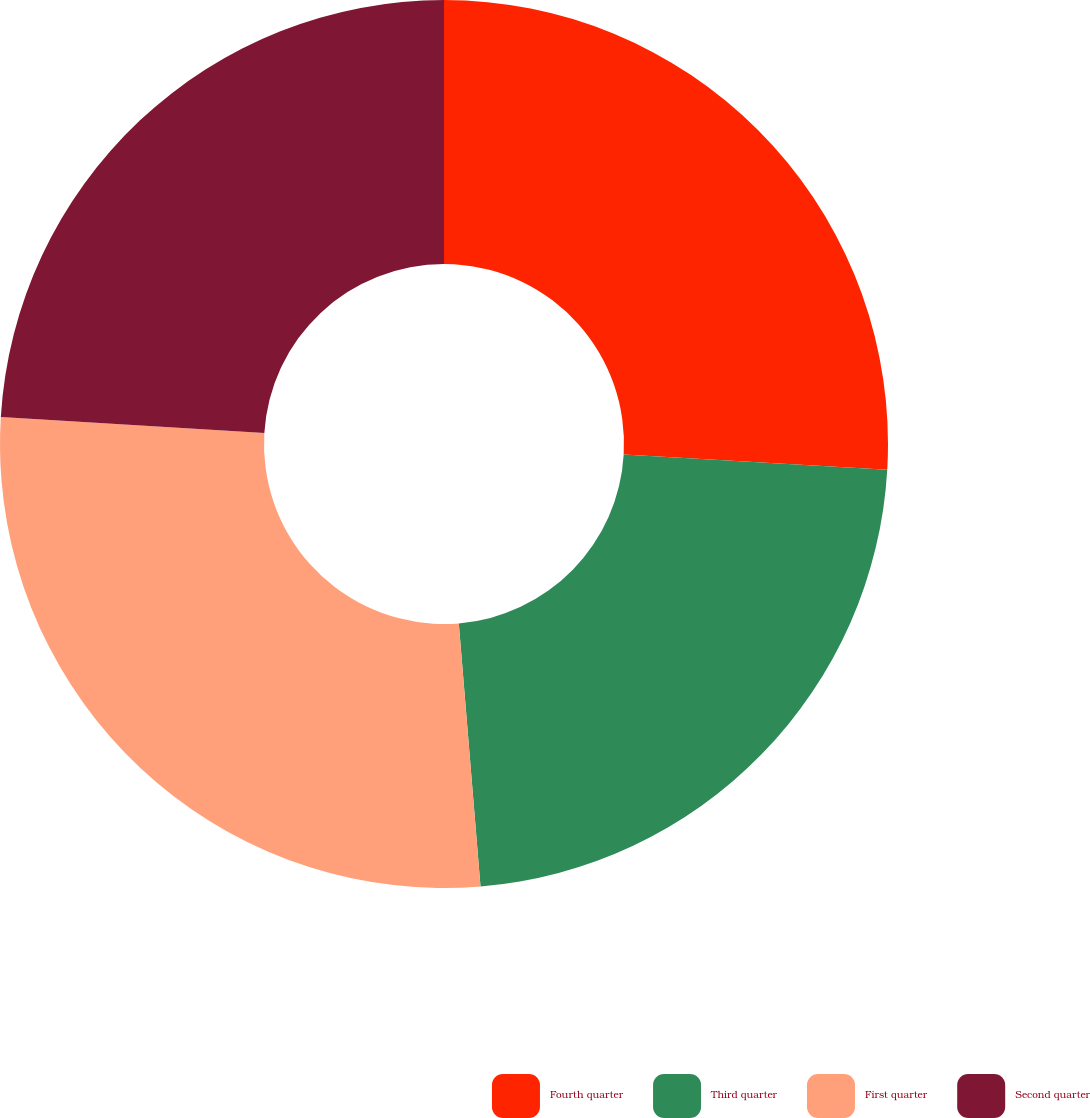Convert chart to OTSL. <chart><loc_0><loc_0><loc_500><loc_500><pie_chart><fcel>Fourth quarter<fcel>Third quarter<fcel>First quarter<fcel>Second quarter<nl><fcel>25.92%<fcel>22.77%<fcel>27.28%<fcel>24.03%<nl></chart> 